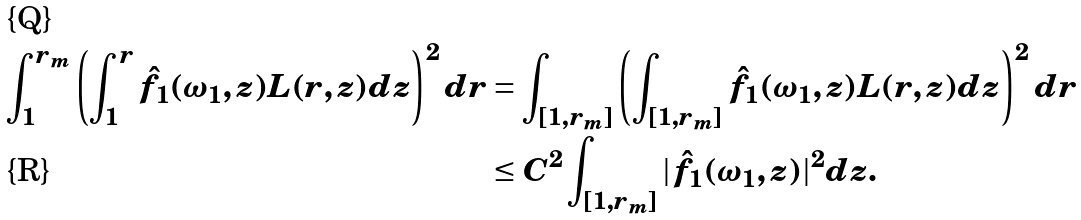Convert formula to latex. <formula><loc_0><loc_0><loc_500><loc_500>\int _ { 1 } ^ { r _ { m } } \left ( \int _ { 1 } ^ { r } \hat { f _ { 1 } } ( \omega _ { 1 } , z ) L ( r , z ) d z \right ) ^ { 2 } d r & = \int _ { [ 1 , r _ { m } ] } \left ( \int _ { [ 1 , r _ { m } ] } \hat { f _ { 1 } } ( \omega _ { 1 } , z ) L ( r , z ) d z \right ) ^ { 2 } d r \\ & \leq C ^ { 2 } \int _ { [ 1 , r _ { m } ] } | \hat { f _ { 1 } } ( \omega _ { 1 } , z ) | ^ { 2 } d z .</formula> 